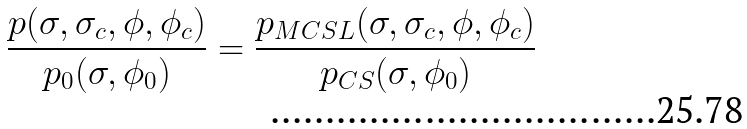Convert formula to latex. <formula><loc_0><loc_0><loc_500><loc_500>\frac { p ( \sigma , \sigma _ { c } , \phi , \phi _ { c } ) } { p _ { 0 } ( \sigma , \phi _ { 0 } ) } = \frac { p _ { M C S L } ( \sigma , \sigma _ { c } , \phi , \phi _ { c } ) } { p _ { C S } ( \sigma , \phi _ { 0 } ) }</formula> 